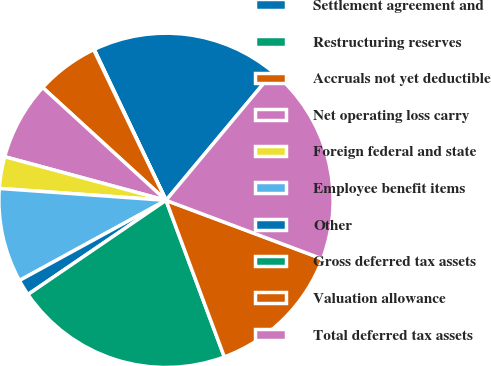<chart> <loc_0><loc_0><loc_500><loc_500><pie_chart><fcel>Settlement agreement and<fcel>Restructuring reserves<fcel>Accruals not yet deductible<fcel>Net operating loss carry<fcel>Foreign federal and state<fcel>Employee benefit items<fcel>Other<fcel>Gross deferred tax assets<fcel>Valuation allowance<fcel>Total deferred tax assets<nl><fcel>18.14%<fcel>0.06%<fcel>6.08%<fcel>7.59%<fcel>3.07%<fcel>9.1%<fcel>1.56%<fcel>21.15%<fcel>13.62%<fcel>19.64%<nl></chart> 